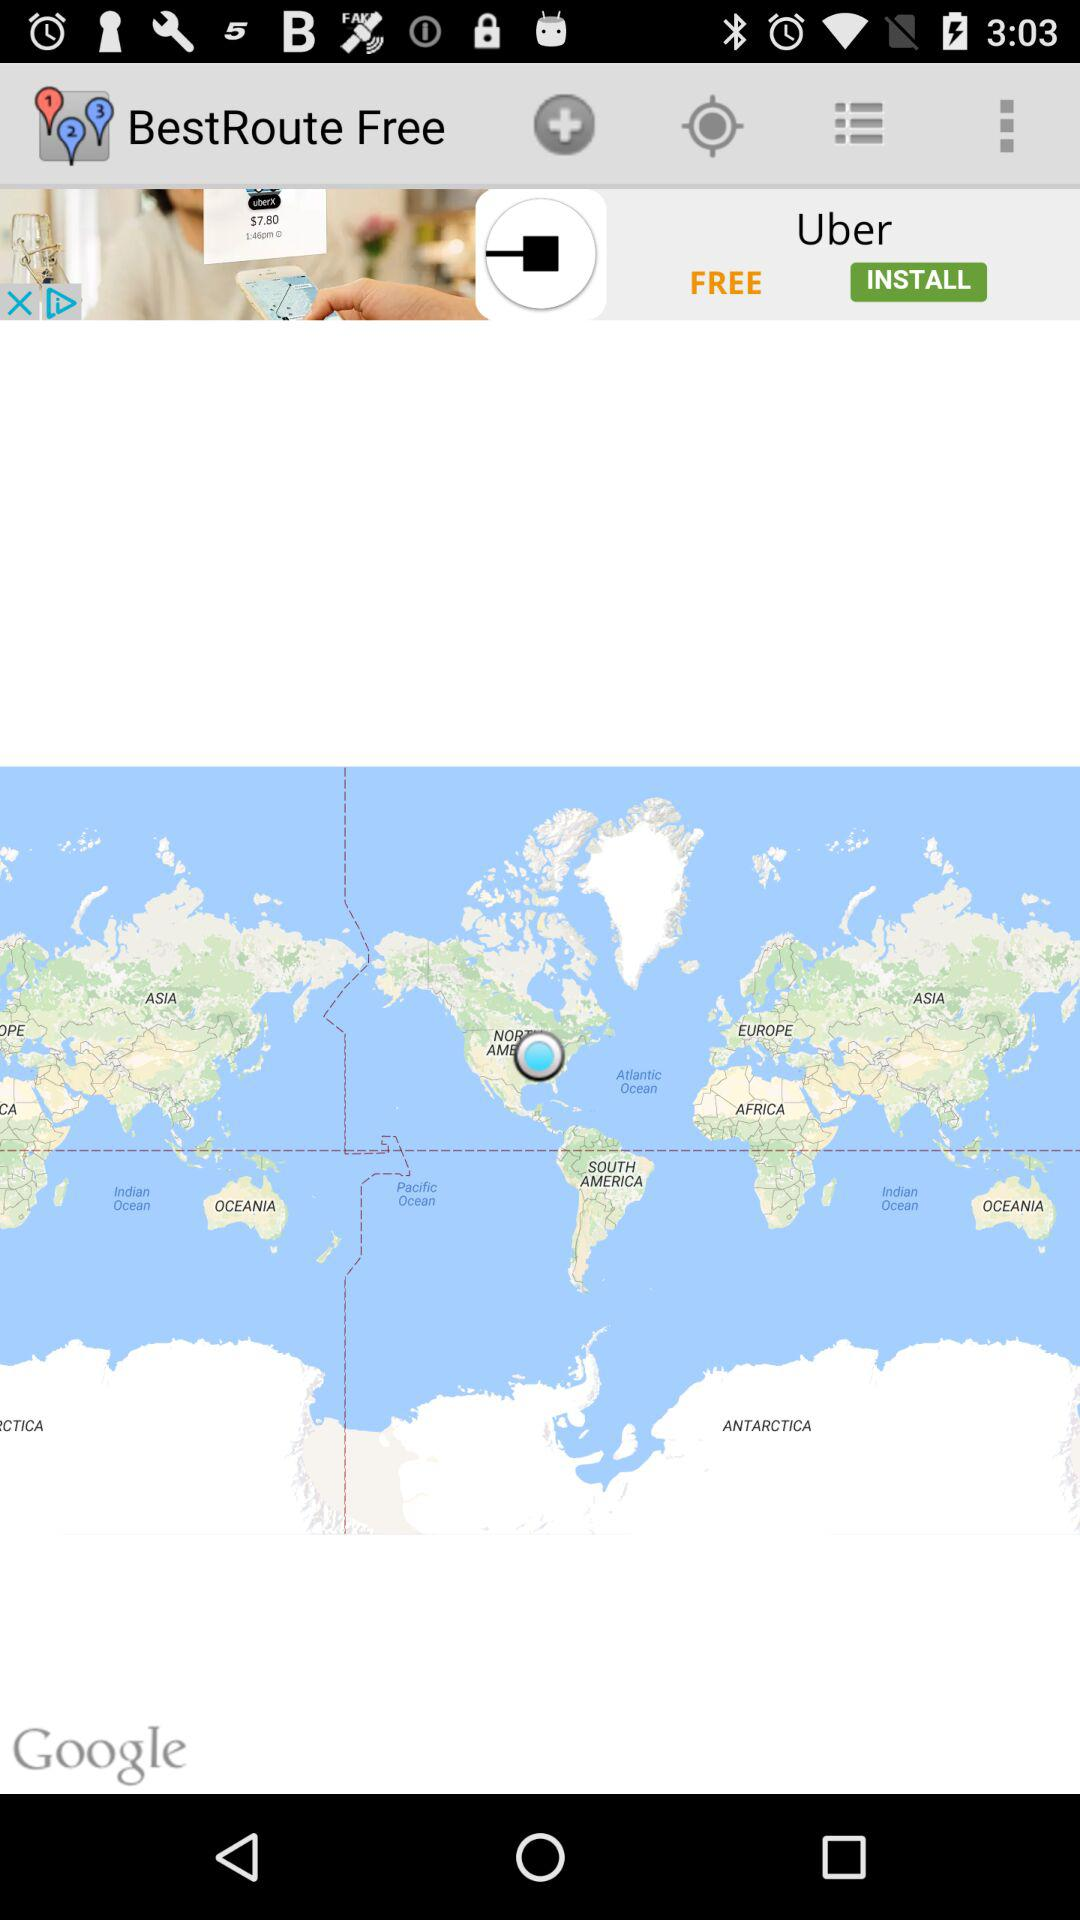What is the name of the application? The name of the application is "BestRoute Free". 